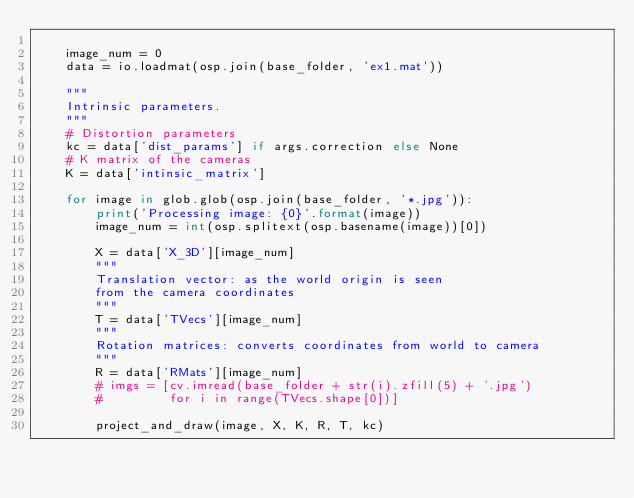Convert code to text. <code><loc_0><loc_0><loc_500><loc_500><_Python_>
    image_num = 0
    data = io.loadmat(osp.join(base_folder, 'ex1.mat'))

    """
    Intrinsic parameters.
    """
    # Distortion parameters
    kc = data['dist_params'] if args.correction else None
    # K matrix of the cameras
    K = data['intinsic_matrix']

    for image in glob.glob(osp.join(base_folder, '*.jpg')):
        print('Processing image: {0}'.format(image))
        image_num = int(osp.splitext(osp.basename(image))[0])

        X = data['X_3D'][image_num]
        """
        Translation vector: as the world origin is seen
        from the camera coordinates
        """
        T = data['TVecs'][image_num]
        """
        Rotation matrices: converts coordinates from world to camera
        """
        R = data['RMats'][image_num]
        # imgs = [cv.imread(base_folder + str(i).zfill(5) + '.jpg')
        #         for i in range(TVecs.shape[0])]

        project_and_draw(image, X, K, R, T, kc)
</code> 